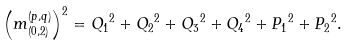<formula> <loc_0><loc_0><loc_500><loc_500>\left ( m ^ { ( p , q ) } _ { ( 0 , 2 ) } \right ) ^ { 2 } = { Q _ { 1 } } ^ { 2 } + { Q _ { 2 } } ^ { 2 } + { Q _ { 3 } } ^ { 2 } + { Q _ { 4 } } ^ { 2 } + { P _ { 1 } } ^ { 2 } + { P _ { 2 } } ^ { 2 } .</formula> 